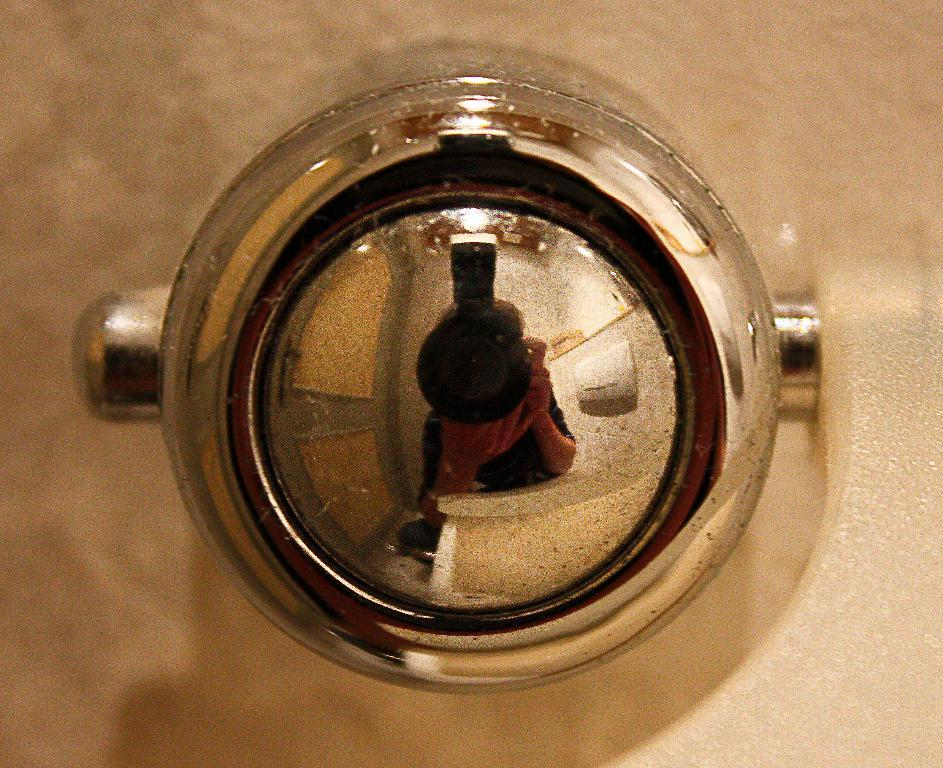What shape is in the center of the image? There is a circle in the center of the image. How many men are using the calculator in the image? There are no men or calculators present in the image; it only features a circle. 